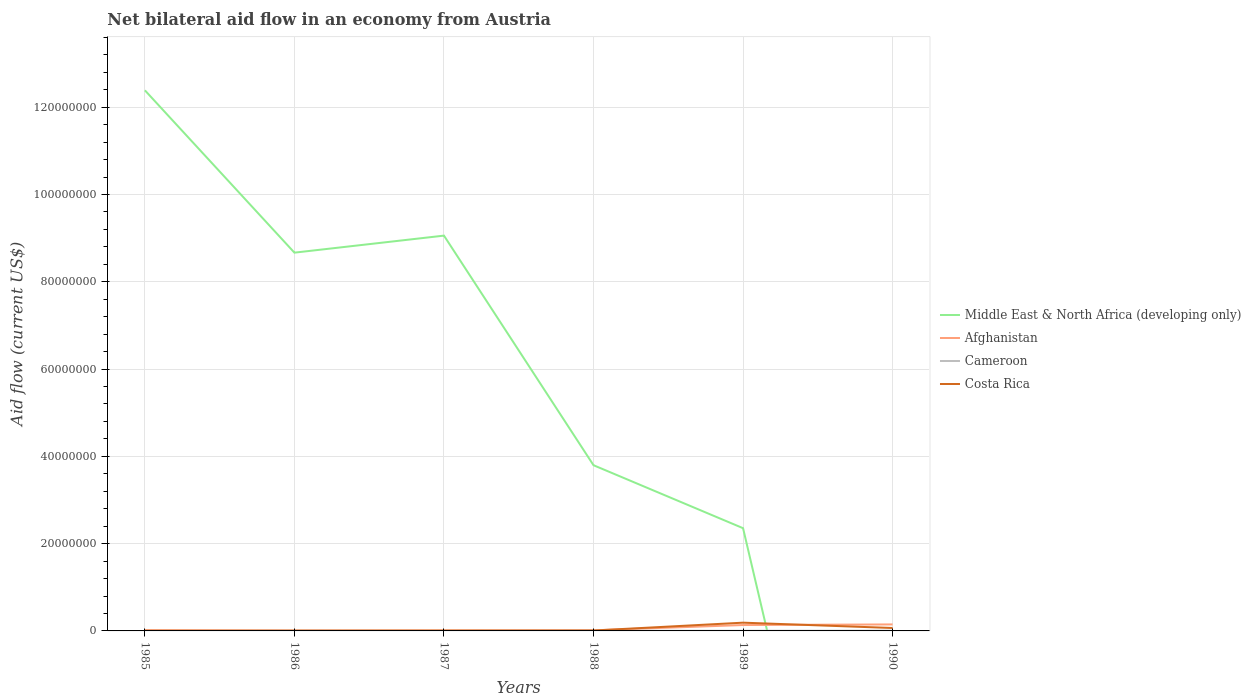How many different coloured lines are there?
Your answer should be very brief. 4. Is the number of lines equal to the number of legend labels?
Your answer should be very brief. No. What is the total net bilateral aid flow in Afghanistan in the graph?
Your response must be concise. -1.18e+06. Is the net bilateral aid flow in Middle East & North Africa (developing only) strictly greater than the net bilateral aid flow in Costa Rica over the years?
Give a very brief answer. No. How many years are there in the graph?
Offer a very short reply. 6. Are the values on the major ticks of Y-axis written in scientific E-notation?
Give a very brief answer. No. Does the graph contain grids?
Offer a terse response. Yes. Where does the legend appear in the graph?
Provide a short and direct response. Center right. How many legend labels are there?
Offer a terse response. 4. What is the title of the graph?
Offer a terse response. Net bilateral aid flow in an economy from Austria. What is the label or title of the Y-axis?
Ensure brevity in your answer.  Aid flow (current US$). What is the Aid flow (current US$) of Middle East & North Africa (developing only) in 1985?
Give a very brief answer. 1.24e+08. What is the Aid flow (current US$) of Afghanistan in 1985?
Your answer should be compact. 1.70e+05. What is the Aid flow (current US$) of Costa Rica in 1985?
Your answer should be compact. 4.00e+04. What is the Aid flow (current US$) in Middle East & North Africa (developing only) in 1986?
Make the answer very short. 8.67e+07. What is the Aid flow (current US$) in Costa Rica in 1986?
Provide a short and direct response. 6.00e+04. What is the Aid flow (current US$) of Middle East & North Africa (developing only) in 1987?
Ensure brevity in your answer.  9.06e+07. What is the Aid flow (current US$) in Afghanistan in 1987?
Keep it short and to the point. 1.10e+05. What is the Aid flow (current US$) in Cameroon in 1987?
Give a very brief answer. 0. What is the Aid flow (current US$) in Middle East & North Africa (developing only) in 1988?
Offer a terse response. 3.80e+07. What is the Aid flow (current US$) of Afghanistan in 1988?
Give a very brief answer. 1.40e+05. What is the Aid flow (current US$) in Costa Rica in 1988?
Your response must be concise. 9.00e+04. What is the Aid flow (current US$) in Middle East & North Africa (developing only) in 1989?
Offer a terse response. 2.35e+07. What is the Aid flow (current US$) in Afghanistan in 1989?
Give a very brief answer. 1.35e+06. What is the Aid flow (current US$) of Costa Rica in 1989?
Your response must be concise. 1.89e+06. What is the Aid flow (current US$) of Afghanistan in 1990?
Your answer should be compact. 1.49e+06. What is the Aid flow (current US$) of Cameroon in 1990?
Make the answer very short. 6.00e+04. What is the Aid flow (current US$) of Costa Rica in 1990?
Keep it short and to the point. 6.70e+05. Across all years, what is the maximum Aid flow (current US$) of Middle East & North Africa (developing only)?
Make the answer very short. 1.24e+08. Across all years, what is the maximum Aid flow (current US$) of Afghanistan?
Your answer should be very brief. 1.49e+06. Across all years, what is the maximum Aid flow (current US$) of Costa Rica?
Your answer should be very brief. 1.89e+06. Across all years, what is the minimum Aid flow (current US$) in Cameroon?
Give a very brief answer. 0. What is the total Aid flow (current US$) in Middle East & North Africa (developing only) in the graph?
Provide a short and direct response. 3.63e+08. What is the total Aid flow (current US$) in Afghanistan in the graph?
Provide a succinct answer. 3.35e+06. What is the total Aid flow (current US$) in Cameroon in the graph?
Your answer should be compact. 1.40e+05. What is the total Aid flow (current US$) of Costa Rica in the graph?
Offer a very short reply. 2.82e+06. What is the difference between the Aid flow (current US$) in Middle East & North Africa (developing only) in 1985 and that in 1986?
Your response must be concise. 3.72e+07. What is the difference between the Aid flow (current US$) of Middle East & North Africa (developing only) in 1985 and that in 1987?
Keep it short and to the point. 3.33e+07. What is the difference between the Aid flow (current US$) in Afghanistan in 1985 and that in 1987?
Give a very brief answer. 6.00e+04. What is the difference between the Aid flow (current US$) of Costa Rica in 1985 and that in 1987?
Give a very brief answer. -3.00e+04. What is the difference between the Aid flow (current US$) in Middle East & North Africa (developing only) in 1985 and that in 1988?
Your response must be concise. 8.59e+07. What is the difference between the Aid flow (current US$) in Afghanistan in 1985 and that in 1988?
Keep it short and to the point. 3.00e+04. What is the difference between the Aid flow (current US$) in Middle East & North Africa (developing only) in 1985 and that in 1989?
Give a very brief answer. 1.00e+08. What is the difference between the Aid flow (current US$) in Afghanistan in 1985 and that in 1989?
Make the answer very short. -1.18e+06. What is the difference between the Aid flow (current US$) of Costa Rica in 1985 and that in 1989?
Provide a succinct answer. -1.85e+06. What is the difference between the Aid flow (current US$) in Afghanistan in 1985 and that in 1990?
Your response must be concise. -1.32e+06. What is the difference between the Aid flow (current US$) of Costa Rica in 1985 and that in 1990?
Offer a very short reply. -6.30e+05. What is the difference between the Aid flow (current US$) in Middle East & North Africa (developing only) in 1986 and that in 1987?
Your response must be concise. -3.90e+06. What is the difference between the Aid flow (current US$) in Costa Rica in 1986 and that in 1987?
Keep it short and to the point. -10000. What is the difference between the Aid flow (current US$) in Middle East & North Africa (developing only) in 1986 and that in 1988?
Ensure brevity in your answer.  4.87e+07. What is the difference between the Aid flow (current US$) in Middle East & North Africa (developing only) in 1986 and that in 1989?
Give a very brief answer. 6.31e+07. What is the difference between the Aid flow (current US$) of Afghanistan in 1986 and that in 1989?
Give a very brief answer. -1.26e+06. What is the difference between the Aid flow (current US$) in Costa Rica in 1986 and that in 1989?
Your response must be concise. -1.83e+06. What is the difference between the Aid flow (current US$) in Afghanistan in 1986 and that in 1990?
Provide a short and direct response. -1.40e+06. What is the difference between the Aid flow (current US$) in Costa Rica in 1986 and that in 1990?
Provide a short and direct response. -6.10e+05. What is the difference between the Aid flow (current US$) in Middle East & North Africa (developing only) in 1987 and that in 1988?
Offer a terse response. 5.26e+07. What is the difference between the Aid flow (current US$) of Afghanistan in 1987 and that in 1988?
Your answer should be very brief. -3.00e+04. What is the difference between the Aid flow (current US$) of Costa Rica in 1987 and that in 1988?
Your response must be concise. -2.00e+04. What is the difference between the Aid flow (current US$) of Middle East & North Africa (developing only) in 1987 and that in 1989?
Give a very brief answer. 6.70e+07. What is the difference between the Aid flow (current US$) of Afghanistan in 1987 and that in 1989?
Your answer should be compact. -1.24e+06. What is the difference between the Aid flow (current US$) of Costa Rica in 1987 and that in 1989?
Your response must be concise. -1.82e+06. What is the difference between the Aid flow (current US$) in Afghanistan in 1987 and that in 1990?
Offer a terse response. -1.38e+06. What is the difference between the Aid flow (current US$) of Costa Rica in 1987 and that in 1990?
Keep it short and to the point. -6.00e+05. What is the difference between the Aid flow (current US$) in Middle East & North Africa (developing only) in 1988 and that in 1989?
Offer a very short reply. 1.44e+07. What is the difference between the Aid flow (current US$) of Afghanistan in 1988 and that in 1989?
Make the answer very short. -1.21e+06. What is the difference between the Aid flow (current US$) of Cameroon in 1988 and that in 1989?
Make the answer very short. -10000. What is the difference between the Aid flow (current US$) of Costa Rica in 1988 and that in 1989?
Your response must be concise. -1.80e+06. What is the difference between the Aid flow (current US$) in Afghanistan in 1988 and that in 1990?
Your answer should be very brief. -1.35e+06. What is the difference between the Aid flow (current US$) of Cameroon in 1988 and that in 1990?
Ensure brevity in your answer.  -3.00e+04. What is the difference between the Aid flow (current US$) of Costa Rica in 1988 and that in 1990?
Ensure brevity in your answer.  -5.80e+05. What is the difference between the Aid flow (current US$) of Costa Rica in 1989 and that in 1990?
Your response must be concise. 1.22e+06. What is the difference between the Aid flow (current US$) of Middle East & North Africa (developing only) in 1985 and the Aid flow (current US$) of Afghanistan in 1986?
Ensure brevity in your answer.  1.24e+08. What is the difference between the Aid flow (current US$) in Middle East & North Africa (developing only) in 1985 and the Aid flow (current US$) in Cameroon in 1986?
Keep it short and to the point. 1.24e+08. What is the difference between the Aid flow (current US$) in Middle East & North Africa (developing only) in 1985 and the Aid flow (current US$) in Costa Rica in 1986?
Ensure brevity in your answer.  1.24e+08. What is the difference between the Aid flow (current US$) of Afghanistan in 1985 and the Aid flow (current US$) of Costa Rica in 1986?
Provide a short and direct response. 1.10e+05. What is the difference between the Aid flow (current US$) of Middle East & North Africa (developing only) in 1985 and the Aid flow (current US$) of Afghanistan in 1987?
Keep it short and to the point. 1.24e+08. What is the difference between the Aid flow (current US$) of Middle East & North Africa (developing only) in 1985 and the Aid flow (current US$) of Costa Rica in 1987?
Offer a very short reply. 1.24e+08. What is the difference between the Aid flow (current US$) in Afghanistan in 1985 and the Aid flow (current US$) in Costa Rica in 1987?
Your answer should be compact. 1.00e+05. What is the difference between the Aid flow (current US$) in Middle East & North Africa (developing only) in 1985 and the Aid flow (current US$) in Afghanistan in 1988?
Offer a terse response. 1.24e+08. What is the difference between the Aid flow (current US$) of Middle East & North Africa (developing only) in 1985 and the Aid flow (current US$) of Cameroon in 1988?
Give a very brief answer. 1.24e+08. What is the difference between the Aid flow (current US$) of Middle East & North Africa (developing only) in 1985 and the Aid flow (current US$) of Costa Rica in 1988?
Keep it short and to the point. 1.24e+08. What is the difference between the Aid flow (current US$) in Middle East & North Africa (developing only) in 1985 and the Aid flow (current US$) in Afghanistan in 1989?
Give a very brief answer. 1.23e+08. What is the difference between the Aid flow (current US$) in Middle East & North Africa (developing only) in 1985 and the Aid flow (current US$) in Cameroon in 1989?
Your response must be concise. 1.24e+08. What is the difference between the Aid flow (current US$) of Middle East & North Africa (developing only) in 1985 and the Aid flow (current US$) of Costa Rica in 1989?
Ensure brevity in your answer.  1.22e+08. What is the difference between the Aid flow (current US$) of Afghanistan in 1985 and the Aid flow (current US$) of Cameroon in 1989?
Offer a very short reply. 1.30e+05. What is the difference between the Aid flow (current US$) of Afghanistan in 1985 and the Aid flow (current US$) of Costa Rica in 1989?
Your answer should be very brief. -1.72e+06. What is the difference between the Aid flow (current US$) of Middle East & North Africa (developing only) in 1985 and the Aid flow (current US$) of Afghanistan in 1990?
Keep it short and to the point. 1.22e+08. What is the difference between the Aid flow (current US$) in Middle East & North Africa (developing only) in 1985 and the Aid flow (current US$) in Cameroon in 1990?
Your response must be concise. 1.24e+08. What is the difference between the Aid flow (current US$) in Middle East & North Africa (developing only) in 1985 and the Aid flow (current US$) in Costa Rica in 1990?
Keep it short and to the point. 1.23e+08. What is the difference between the Aid flow (current US$) of Afghanistan in 1985 and the Aid flow (current US$) of Costa Rica in 1990?
Your response must be concise. -5.00e+05. What is the difference between the Aid flow (current US$) in Middle East & North Africa (developing only) in 1986 and the Aid flow (current US$) in Afghanistan in 1987?
Offer a terse response. 8.66e+07. What is the difference between the Aid flow (current US$) of Middle East & North Africa (developing only) in 1986 and the Aid flow (current US$) of Costa Rica in 1987?
Your answer should be compact. 8.66e+07. What is the difference between the Aid flow (current US$) of Middle East & North Africa (developing only) in 1986 and the Aid flow (current US$) of Afghanistan in 1988?
Your answer should be compact. 8.65e+07. What is the difference between the Aid flow (current US$) in Middle East & North Africa (developing only) in 1986 and the Aid flow (current US$) in Cameroon in 1988?
Make the answer very short. 8.66e+07. What is the difference between the Aid flow (current US$) of Middle East & North Africa (developing only) in 1986 and the Aid flow (current US$) of Costa Rica in 1988?
Ensure brevity in your answer.  8.66e+07. What is the difference between the Aid flow (current US$) in Afghanistan in 1986 and the Aid flow (current US$) in Costa Rica in 1988?
Offer a terse response. 0. What is the difference between the Aid flow (current US$) in Middle East & North Africa (developing only) in 1986 and the Aid flow (current US$) in Afghanistan in 1989?
Your response must be concise. 8.53e+07. What is the difference between the Aid flow (current US$) of Middle East & North Africa (developing only) in 1986 and the Aid flow (current US$) of Cameroon in 1989?
Your answer should be very brief. 8.66e+07. What is the difference between the Aid flow (current US$) of Middle East & North Africa (developing only) in 1986 and the Aid flow (current US$) of Costa Rica in 1989?
Your response must be concise. 8.48e+07. What is the difference between the Aid flow (current US$) in Afghanistan in 1986 and the Aid flow (current US$) in Cameroon in 1989?
Offer a very short reply. 5.00e+04. What is the difference between the Aid flow (current US$) of Afghanistan in 1986 and the Aid flow (current US$) of Costa Rica in 1989?
Ensure brevity in your answer.  -1.80e+06. What is the difference between the Aid flow (current US$) of Cameroon in 1986 and the Aid flow (current US$) of Costa Rica in 1989?
Your response must be concise. -1.88e+06. What is the difference between the Aid flow (current US$) in Middle East & North Africa (developing only) in 1986 and the Aid flow (current US$) in Afghanistan in 1990?
Provide a short and direct response. 8.52e+07. What is the difference between the Aid flow (current US$) in Middle East & North Africa (developing only) in 1986 and the Aid flow (current US$) in Cameroon in 1990?
Ensure brevity in your answer.  8.66e+07. What is the difference between the Aid flow (current US$) of Middle East & North Africa (developing only) in 1986 and the Aid flow (current US$) of Costa Rica in 1990?
Provide a succinct answer. 8.60e+07. What is the difference between the Aid flow (current US$) in Afghanistan in 1986 and the Aid flow (current US$) in Costa Rica in 1990?
Provide a short and direct response. -5.80e+05. What is the difference between the Aid flow (current US$) of Cameroon in 1986 and the Aid flow (current US$) of Costa Rica in 1990?
Your answer should be very brief. -6.60e+05. What is the difference between the Aid flow (current US$) in Middle East & North Africa (developing only) in 1987 and the Aid flow (current US$) in Afghanistan in 1988?
Make the answer very short. 9.04e+07. What is the difference between the Aid flow (current US$) of Middle East & North Africa (developing only) in 1987 and the Aid flow (current US$) of Cameroon in 1988?
Your response must be concise. 9.06e+07. What is the difference between the Aid flow (current US$) in Middle East & North Africa (developing only) in 1987 and the Aid flow (current US$) in Costa Rica in 1988?
Offer a very short reply. 9.05e+07. What is the difference between the Aid flow (current US$) in Middle East & North Africa (developing only) in 1987 and the Aid flow (current US$) in Afghanistan in 1989?
Ensure brevity in your answer.  8.92e+07. What is the difference between the Aid flow (current US$) in Middle East & North Africa (developing only) in 1987 and the Aid flow (current US$) in Cameroon in 1989?
Your answer should be compact. 9.05e+07. What is the difference between the Aid flow (current US$) in Middle East & North Africa (developing only) in 1987 and the Aid flow (current US$) in Costa Rica in 1989?
Provide a succinct answer. 8.87e+07. What is the difference between the Aid flow (current US$) in Afghanistan in 1987 and the Aid flow (current US$) in Cameroon in 1989?
Offer a terse response. 7.00e+04. What is the difference between the Aid flow (current US$) of Afghanistan in 1987 and the Aid flow (current US$) of Costa Rica in 1989?
Keep it short and to the point. -1.78e+06. What is the difference between the Aid flow (current US$) in Middle East & North Africa (developing only) in 1987 and the Aid flow (current US$) in Afghanistan in 1990?
Ensure brevity in your answer.  8.91e+07. What is the difference between the Aid flow (current US$) in Middle East & North Africa (developing only) in 1987 and the Aid flow (current US$) in Cameroon in 1990?
Offer a terse response. 9.05e+07. What is the difference between the Aid flow (current US$) in Middle East & North Africa (developing only) in 1987 and the Aid flow (current US$) in Costa Rica in 1990?
Your response must be concise. 8.99e+07. What is the difference between the Aid flow (current US$) of Afghanistan in 1987 and the Aid flow (current US$) of Costa Rica in 1990?
Offer a very short reply. -5.60e+05. What is the difference between the Aid flow (current US$) of Middle East & North Africa (developing only) in 1988 and the Aid flow (current US$) of Afghanistan in 1989?
Keep it short and to the point. 3.66e+07. What is the difference between the Aid flow (current US$) in Middle East & North Africa (developing only) in 1988 and the Aid flow (current US$) in Cameroon in 1989?
Your answer should be very brief. 3.79e+07. What is the difference between the Aid flow (current US$) of Middle East & North Africa (developing only) in 1988 and the Aid flow (current US$) of Costa Rica in 1989?
Your response must be concise. 3.61e+07. What is the difference between the Aid flow (current US$) in Afghanistan in 1988 and the Aid flow (current US$) in Costa Rica in 1989?
Keep it short and to the point. -1.75e+06. What is the difference between the Aid flow (current US$) in Cameroon in 1988 and the Aid flow (current US$) in Costa Rica in 1989?
Offer a terse response. -1.86e+06. What is the difference between the Aid flow (current US$) of Middle East & North Africa (developing only) in 1988 and the Aid flow (current US$) of Afghanistan in 1990?
Offer a very short reply. 3.65e+07. What is the difference between the Aid flow (current US$) of Middle East & North Africa (developing only) in 1988 and the Aid flow (current US$) of Cameroon in 1990?
Give a very brief answer. 3.79e+07. What is the difference between the Aid flow (current US$) of Middle East & North Africa (developing only) in 1988 and the Aid flow (current US$) of Costa Rica in 1990?
Give a very brief answer. 3.73e+07. What is the difference between the Aid flow (current US$) of Afghanistan in 1988 and the Aid flow (current US$) of Costa Rica in 1990?
Offer a terse response. -5.30e+05. What is the difference between the Aid flow (current US$) in Cameroon in 1988 and the Aid flow (current US$) in Costa Rica in 1990?
Give a very brief answer. -6.40e+05. What is the difference between the Aid flow (current US$) of Middle East & North Africa (developing only) in 1989 and the Aid flow (current US$) of Afghanistan in 1990?
Offer a terse response. 2.20e+07. What is the difference between the Aid flow (current US$) of Middle East & North Africa (developing only) in 1989 and the Aid flow (current US$) of Cameroon in 1990?
Provide a short and direct response. 2.35e+07. What is the difference between the Aid flow (current US$) in Middle East & North Africa (developing only) in 1989 and the Aid flow (current US$) in Costa Rica in 1990?
Give a very brief answer. 2.29e+07. What is the difference between the Aid flow (current US$) in Afghanistan in 1989 and the Aid flow (current US$) in Cameroon in 1990?
Give a very brief answer. 1.29e+06. What is the difference between the Aid flow (current US$) of Afghanistan in 1989 and the Aid flow (current US$) of Costa Rica in 1990?
Ensure brevity in your answer.  6.80e+05. What is the difference between the Aid flow (current US$) in Cameroon in 1989 and the Aid flow (current US$) in Costa Rica in 1990?
Your response must be concise. -6.30e+05. What is the average Aid flow (current US$) of Middle East & North Africa (developing only) per year?
Your answer should be very brief. 6.04e+07. What is the average Aid flow (current US$) in Afghanistan per year?
Offer a very short reply. 5.58e+05. What is the average Aid flow (current US$) of Cameroon per year?
Provide a succinct answer. 2.33e+04. In the year 1985, what is the difference between the Aid flow (current US$) in Middle East & North Africa (developing only) and Aid flow (current US$) in Afghanistan?
Provide a short and direct response. 1.24e+08. In the year 1985, what is the difference between the Aid flow (current US$) of Middle East & North Africa (developing only) and Aid flow (current US$) of Costa Rica?
Your answer should be compact. 1.24e+08. In the year 1985, what is the difference between the Aid flow (current US$) in Afghanistan and Aid flow (current US$) in Costa Rica?
Your response must be concise. 1.30e+05. In the year 1986, what is the difference between the Aid flow (current US$) of Middle East & North Africa (developing only) and Aid flow (current US$) of Afghanistan?
Keep it short and to the point. 8.66e+07. In the year 1986, what is the difference between the Aid flow (current US$) in Middle East & North Africa (developing only) and Aid flow (current US$) in Cameroon?
Your answer should be compact. 8.67e+07. In the year 1986, what is the difference between the Aid flow (current US$) of Middle East & North Africa (developing only) and Aid flow (current US$) of Costa Rica?
Keep it short and to the point. 8.66e+07. In the year 1987, what is the difference between the Aid flow (current US$) of Middle East & North Africa (developing only) and Aid flow (current US$) of Afghanistan?
Ensure brevity in your answer.  9.05e+07. In the year 1987, what is the difference between the Aid flow (current US$) of Middle East & North Africa (developing only) and Aid flow (current US$) of Costa Rica?
Provide a succinct answer. 9.05e+07. In the year 1988, what is the difference between the Aid flow (current US$) of Middle East & North Africa (developing only) and Aid flow (current US$) of Afghanistan?
Make the answer very short. 3.78e+07. In the year 1988, what is the difference between the Aid flow (current US$) of Middle East & North Africa (developing only) and Aid flow (current US$) of Cameroon?
Provide a short and direct response. 3.79e+07. In the year 1988, what is the difference between the Aid flow (current US$) of Middle East & North Africa (developing only) and Aid flow (current US$) of Costa Rica?
Your response must be concise. 3.79e+07. In the year 1988, what is the difference between the Aid flow (current US$) of Afghanistan and Aid flow (current US$) of Costa Rica?
Keep it short and to the point. 5.00e+04. In the year 1989, what is the difference between the Aid flow (current US$) in Middle East & North Africa (developing only) and Aid flow (current US$) in Afghanistan?
Make the answer very short. 2.22e+07. In the year 1989, what is the difference between the Aid flow (current US$) of Middle East & North Africa (developing only) and Aid flow (current US$) of Cameroon?
Keep it short and to the point. 2.35e+07. In the year 1989, what is the difference between the Aid flow (current US$) of Middle East & North Africa (developing only) and Aid flow (current US$) of Costa Rica?
Provide a succinct answer. 2.16e+07. In the year 1989, what is the difference between the Aid flow (current US$) of Afghanistan and Aid flow (current US$) of Cameroon?
Your answer should be very brief. 1.31e+06. In the year 1989, what is the difference between the Aid flow (current US$) of Afghanistan and Aid flow (current US$) of Costa Rica?
Your answer should be very brief. -5.40e+05. In the year 1989, what is the difference between the Aid flow (current US$) in Cameroon and Aid flow (current US$) in Costa Rica?
Make the answer very short. -1.85e+06. In the year 1990, what is the difference between the Aid flow (current US$) in Afghanistan and Aid flow (current US$) in Cameroon?
Offer a terse response. 1.43e+06. In the year 1990, what is the difference between the Aid flow (current US$) in Afghanistan and Aid flow (current US$) in Costa Rica?
Offer a very short reply. 8.20e+05. In the year 1990, what is the difference between the Aid flow (current US$) in Cameroon and Aid flow (current US$) in Costa Rica?
Provide a succinct answer. -6.10e+05. What is the ratio of the Aid flow (current US$) in Middle East & North Africa (developing only) in 1985 to that in 1986?
Offer a terse response. 1.43. What is the ratio of the Aid flow (current US$) in Afghanistan in 1985 to that in 1986?
Provide a succinct answer. 1.89. What is the ratio of the Aid flow (current US$) of Middle East & North Africa (developing only) in 1985 to that in 1987?
Give a very brief answer. 1.37. What is the ratio of the Aid flow (current US$) of Afghanistan in 1985 to that in 1987?
Your response must be concise. 1.55. What is the ratio of the Aid flow (current US$) in Middle East & North Africa (developing only) in 1985 to that in 1988?
Keep it short and to the point. 3.26. What is the ratio of the Aid flow (current US$) of Afghanistan in 1985 to that in 1988?
Your answer should be compact. 1.21. What is the ratio of the Aid flow (current US$) in Costa Rica in 1985 to that in 1988?
Provide a succinct answer. 0.44. What is the ratio of the Aid flow (current US$) of Middle East & North Africa (developing only) in 1985 to that in 1989?
Offer a terse response. 5.26. What is the ratio of the Aid flow (current US$) in Afghanistan in 1985 to that in 1989?
Provide a succinct answer. 0.13. What is the ratio of the Aid flow (current US$) in Costa Rica in 1985 to that in 1989?
Ensure brevity in your answer.  0.02. What is the ratio of the Aid flow (current US$) in Afghanistan in 1985 to that in 1990?
Keep it short and to the point. 0.11. What is the ratio of the Aid flow (current US$) of Costa Rica in 1985 to that in 1990?
Make the answer very short. 0.06. What is the ratio of the Aid flow (current US$) in Middle East & North Africa (developing only) in 1986 to that in 1987?
Keep it short and to the point. 0.96. What is the ratio of the Aid flow (current US$) in Afghanistan in 1986 to that in 1987?
Ensure brevity in your answer.  0.82. What is the ratio of the Aid flow (current US$) of Costa Rica in 1986 to that in 1987?
Ensure brevity in your answer.  0.86. What is the ratio of the Aid flow (current US$) in Middle East & North Africa (developing only) in 1986 to that in 1988?
Offer a very short reply. 2.28. What is the ratio of the Aid flow (current US$) of Afghanistan in 1986 to that in 1988?
Give a very brief answer. 0.64. What is the ratio of the Aid flow (current US$) of Cameroon in 1986 to that in 1988?
Keep it short and to the point. 0.33. What is the ratio of the Aid flow (current US$) of Middle East & North Africa (developing only) in 1986 to that in 1989?
Provide a short and direct response. 3.68. What is the ratio of the Aid flow (current US$) in Afghanistan in 1986 to that in 1989?
Offer a very short reply. 0.07. What is the ratio of the Aid flow (current US$) in Costa Rica in 1986 to that in 1989?
Provide a short and direct response. 0.03. What is the ratio of the Aid flow (current US$) in Afghanistan in 1986 to that in 1990?
Your answer should be very brief. 0.06. What is the ratio of the Aid flow (current US$) in Costa Rica in 1986 to that in 1990?
Your answer should be very brief. 0.09. What is the ratio of the Aid flow (current US$) of Middle East & North Africa (developing only) in 1987 to that in 1988?
Make the answer very short. 2.39. What is the ratio of the Aid flow (current US$) of Afghanistan in 1987 to that in 1988?
Provide a short and direct response. 0.79. What is the ratio of the Aid flow (current US$) of Costa Rica in 1987 to that in 1988?
Your answer should be very brief. 0.78. What is the ratio of the Aid flow (current US$) of Middle East & North Africa (developing only) in 1987 to that in 1989?
Your answer should be compact. 3.85. What is the ratio of the Aid flow (current US$) in Afghanistan in 1987 to that in 1989?
Give a very brief answer. 0.08. What is the ratio of the Aid flow (current US$) of Costa Rica in 1987 to that in 1989?
Make the answer very short. 0.04. What is the ratio of the Aid flow (current US$) in Afghanistan in 1987 to that in 1990?
Provide a short and direct response. 0.07. What is the ratio of the Aid flow (current US$) in Costa Rica in 1987 to that in 1990?
Offer a terse response. 0.1. What is the ratio of the Aid flow (current US$) of Middle East & North Africa (developing only) in 1988 to that in 1989?
Your response must be concise. 1.61. What is the ratio of the Aid flow (current US$) of Afghanistan in 1988 to that in 1989?
Your answer should be very brief. 0.1. What is the ratio of the Aid flow (current US$) of Costa Rica in 1988 to that in 1989?
Your response must be concise. 0.05. What is the ratio of the Aid flow (current US$) of Afghanistan in 1988 to that in 1990?
Provide a succinct answer. 0.09. What is the ratio of the Aid flow (current US$) in Costa Rica in 1988 to that in 1990?
Offer a very short reply. 0.13. What is the ratio of the Aid flow (current US$) of Afghanistan in 1989 to that in 1990?
Offer a very short reply. 0.91. What is the ratio of the Aid flow (current US$) in Costa Rica in 1989 to that in 1990?
Your answer should be very brief. 2.82. What is the difference between the highest and the second highest Aid flow (current US$) of Middle East & North Africa (developing only)?
Give a very brief answer. 3.33e+07. What is the difference between the highest and the second highest Aid flow (current US$) in Costa Rica?
Make the answer very short. 1.22e+06. What is the difference between the highest and the lowest Aid flow (current US$) in Middle East & North Africa (developing only)?
Keep it short and to the point. 1.24e+08. What is the difference between the highest and the lowest Aid flow (current US$) in Afghanistan?
Your answer should be very brief. 1.40e+06. What is the difference between the highest and the lowest Aid flow (current US$) of Costa Rica?
Offer a terse response. 1.85e+06. 